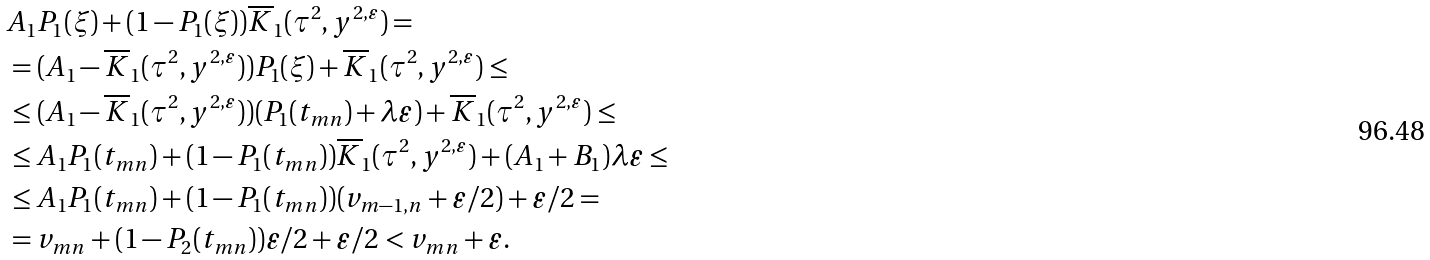<formula> <loc_0><loc_0><loc_500><loc_500>& A _ { 1 } P _ { 1 } ( \xi ) + ( 1 - P _ { 1 } ( \xi ) ) \overline { K } _ { 1 } ( \tau ^ { 2 } , y ^ { 2 , \varepsilon } ) = \\ & = ( A _ { 1 } - \overline { K } _ { 1 } ( \tau ^ { 2 } , y ^ { 2 , \varepsilon } ) ) P _ { 1 } ( \xi ) + \overline { K } _ { 1 } ( \tau ^ { 2 } , y ^ { 2 , \varepsilon } ) \leq \\ & \leq ( A _ { 1 } - \overline { K } _ { 1 } ( \tau ^ { 2 } , y ^ { 2 , \varepsilon } ) ) ( P _ { 1 } ( t _ { m n } ) + \lambda \varepsilon ) + \overline { K } _ { 1 } ( \tau ^ { 2 } , y ^ { 2 , \varepsilon } ) \leq \\ & \leq A _ { 1 } P _ { 1 } ( t _ { m n } ) + ( 1 - P _ { 1 } ( t _ { m n } ) ) \overline { K } _ { 1 } ( \tau ^ { 2 } , y ^ { 2 , \varepsilon } ) + ( A _ { 1 } + B _ { 1 } ) \lambda \varepsilon \leq \\ & \leq A _ { 1 } P _ { 1 } ( t _ { m n } ) + ( 1 - P _ { 1 } ( t _ { m n } ) ) ( v _ { m - 1 , n } + \varepsilon / 2 ) + \varepsilon / 2 = \\ & = v _ { m n } + ( 1 - P _ { 2 } ( t _ { m n } ) ) \varepsilon / 2 + \varepsilon / 2 < v _ { m n } + \varepsilon .</formula> 